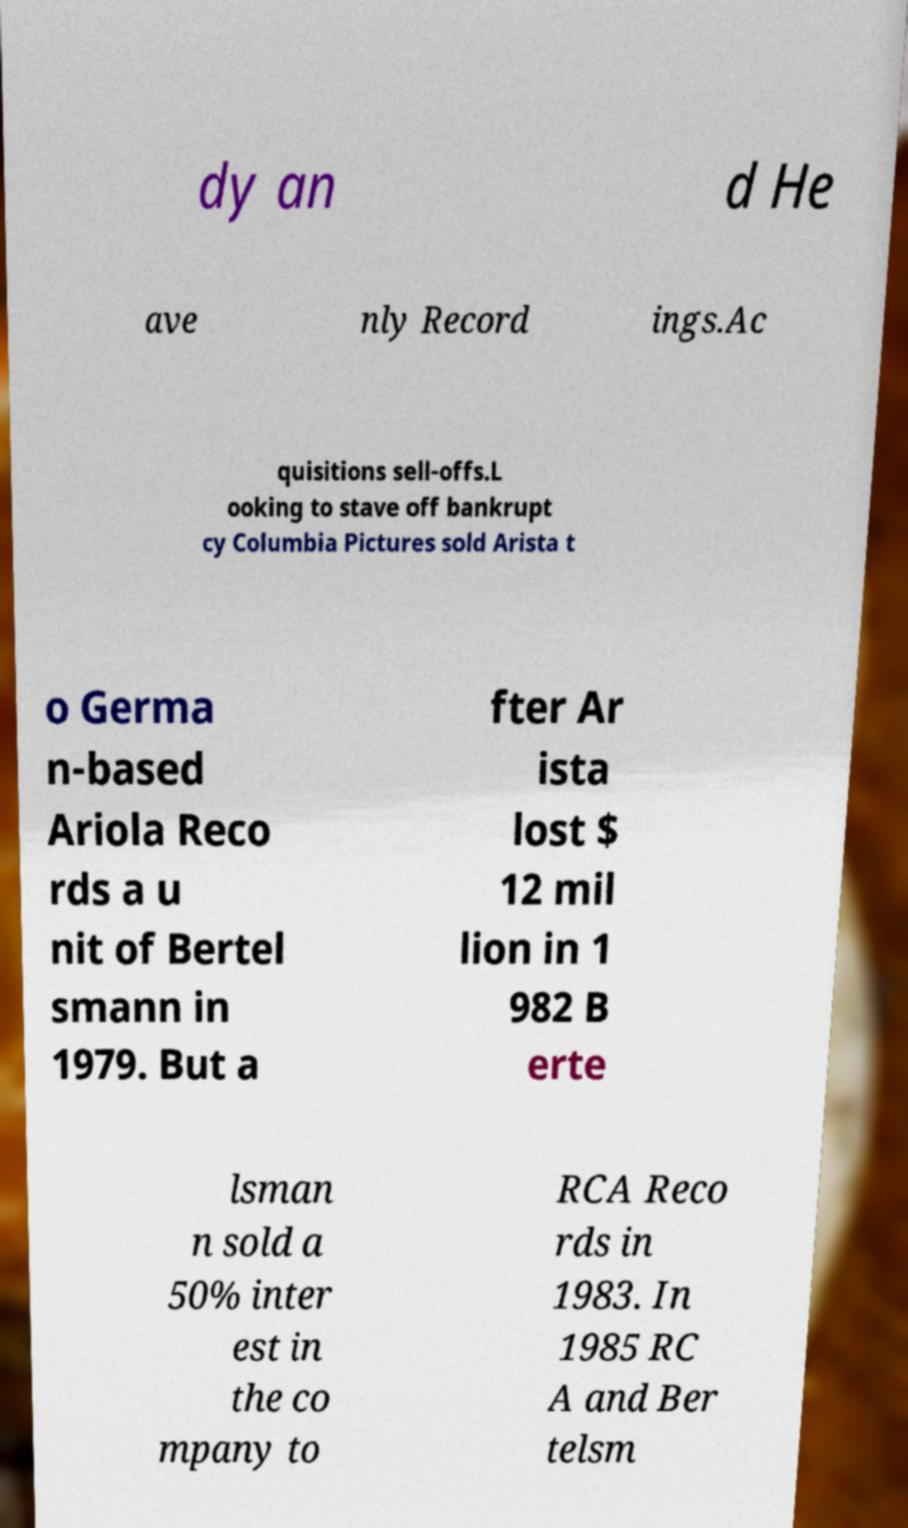Please identify and transcribe the text found in this image. dy an d He ave nly Record ings.Ac quisitions sell-offs.L ooking to stave off bankrupt cy Columbia Pictures sold Arista t o Germa n-based Ariola Reco rds a u nit of Bertel smann in 1979. But a fter Ar ista lost $ 12 mil lion in 1 982 B erte lsman n sold a 50% inter est in the co mpany to RCA Reco rds in 1983. In 1985 RC A and Ber telsm 